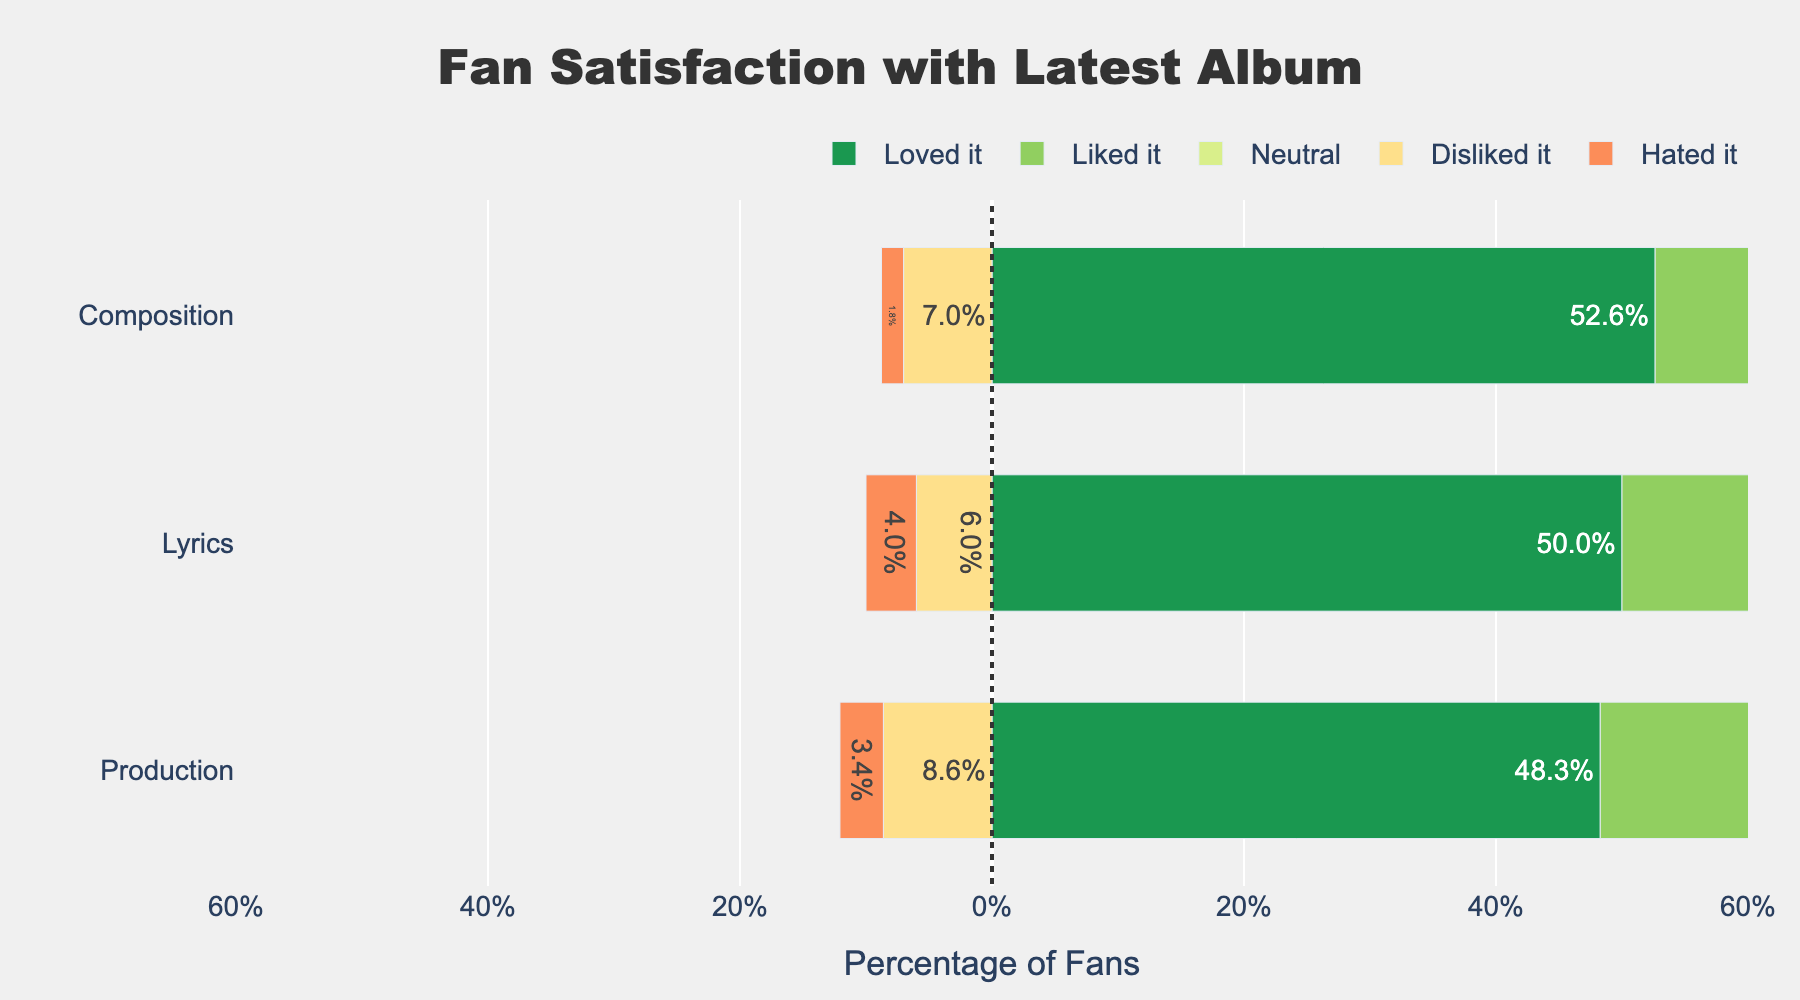What satisfaction level had the highest percentage for the Lyrics? Look at the bar that represents the 'Loved it' satisfaction level for Lyrics.
Answer: Loved it Which aspect (Lyrics, Composition, Production) has the most 'Liked it' ratings? Compare the lengths of the 'Liked it' bars for all three categories looking for the longest one.
Answer: Composition How much more percentage of fans "Loved it" than "Hated it" in Production? Subtract the 'Hated it' bar percentage from the 'Loved it' bar percentage for Production.
Answer: 56% Which aspect has the highest combined dissatisfaction (Disliked it + Hated it)? Add the percentages of 'Disliked it' and 'Hated it' for each aspect and compare them.
Answer: Production What is the percentage of fans who felt neutral about the Composition? Look at the 'Neutral' bar for Composition and note the percentage.
Answer: 12.8% Is the number of fans who 'Loved it' for Composition higher or lower than that for Lyrics? Compare the lengths of the 'Loved it' bars for Composition and Lyrics.
Answer: Higher Which satisfaction level shows the smallest difference in percentage between Lyrics and Production? Calculate the percentage difference for each satisfaction level between Lyrics and Production, then identify the smallest one.
Answer: Hated it How does the percentage of fans who disliked the Lyrics compare to those who disliked the Production? Compare the lengths of the 'Disliked it' bars for Lyrics and Production.
Answer: Lower Which category has the closest percentage of neutral ratings? Compare the lengths of the 'Neutral' bars for each category, looking for the closest values.
Answer: Composition and Production 